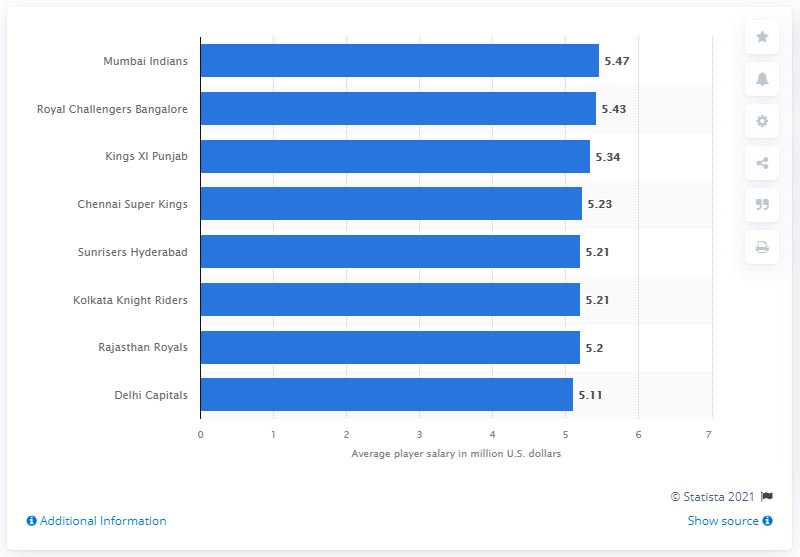Mention a couple of crucial points in this snapshot. Kings XI Punjab placed third in the 2019 IPL season. The average annual salary of a Mumbai Indians player in the 2019 season was Rs. 5.47 crores. 